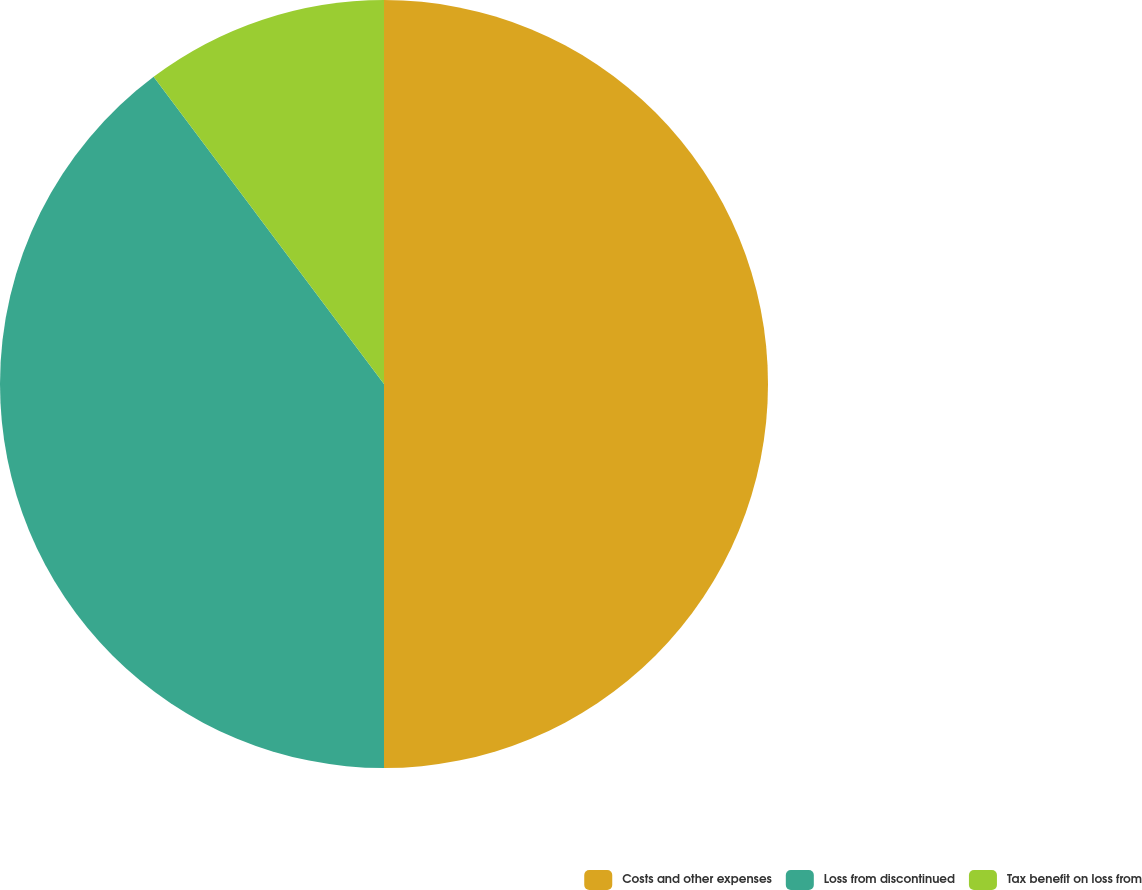<chart> <loc_0><loc_0><loc_500><loc_500><pie_chart><fcel>Costs and other expenses<fcel>Loss from discontinued<fcel>Tax benefit on loss from<nl><fcel>50.0%<fcel>39.76%<fcel>10.24%<nl></chart> 